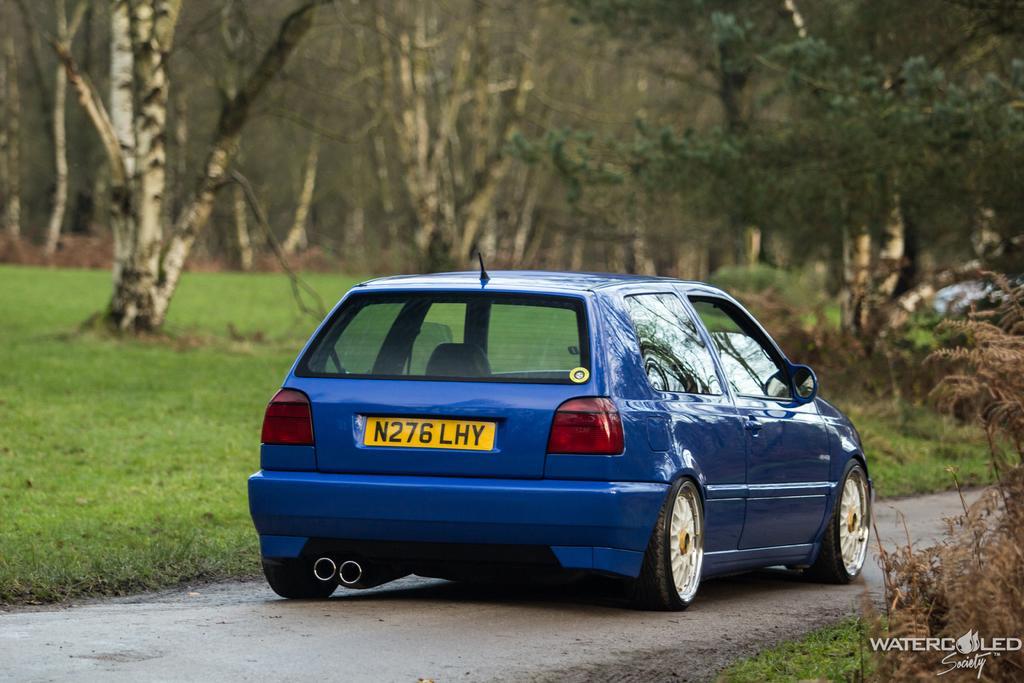In one or two sentences, can you explain what this image depicts? In the image we can see a vehicle on the road. Here we can see grass, trees, dry plant and on the bottom right we can see the watermark. 